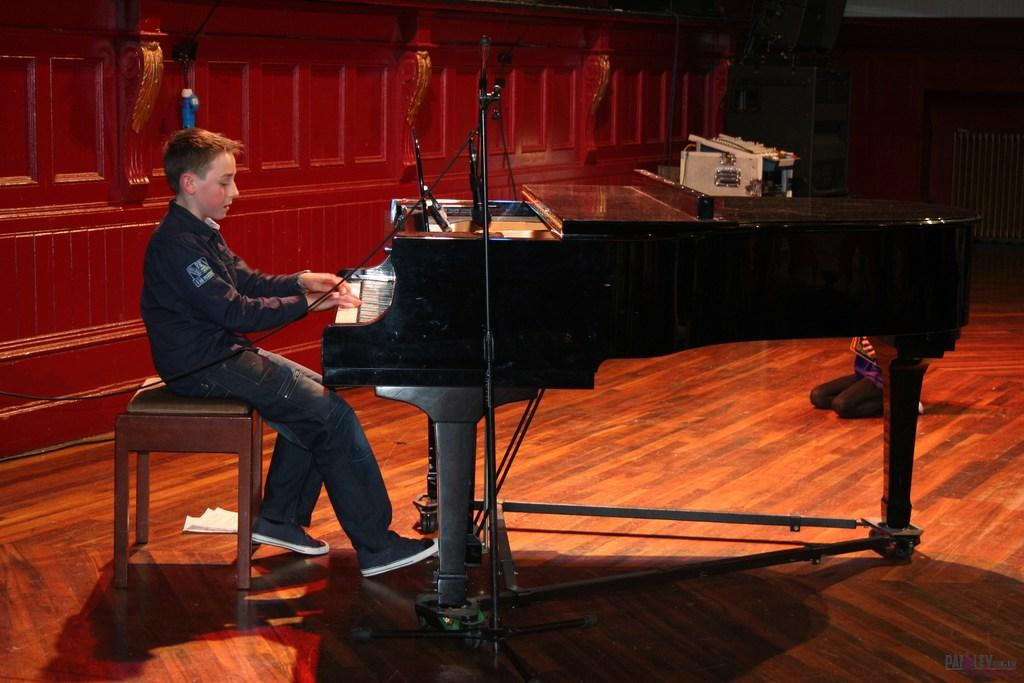Who is the main subject in the image? There is a boy in the image. What is the boy doing in the image? The boy is sitting on a chair and playing a keyboard, a musical instrument. What can be seen on the floor in the image? There are papers on the floor. What type of pear is the boy holding in the image? There is no pear present in the image; the boy is playing a keyboard. Can you see a worm crawling on the floor in the image? There is no worm visible in the image; only papers on the floor are mentioned. 